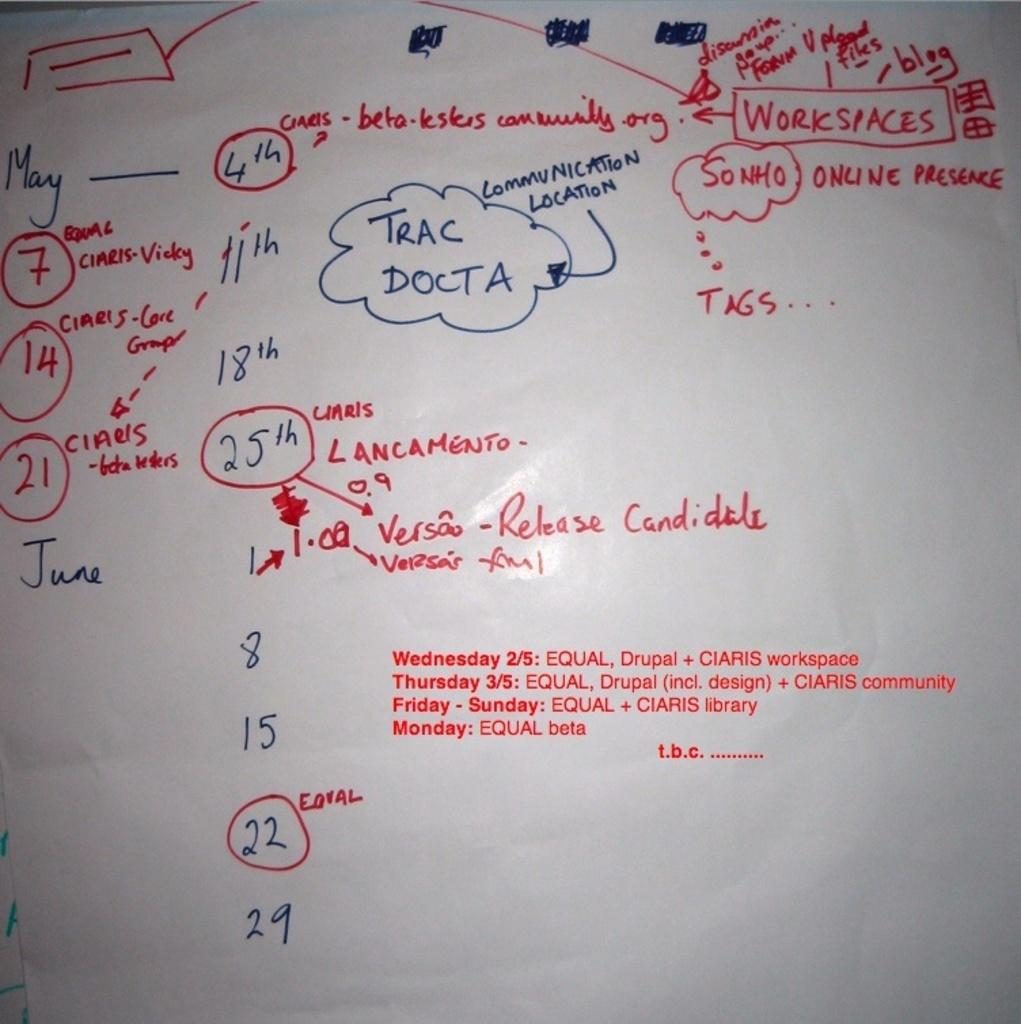<image>
Render a clear and concise summary of the photo. White board with the words "Communication Location" in the middle. 